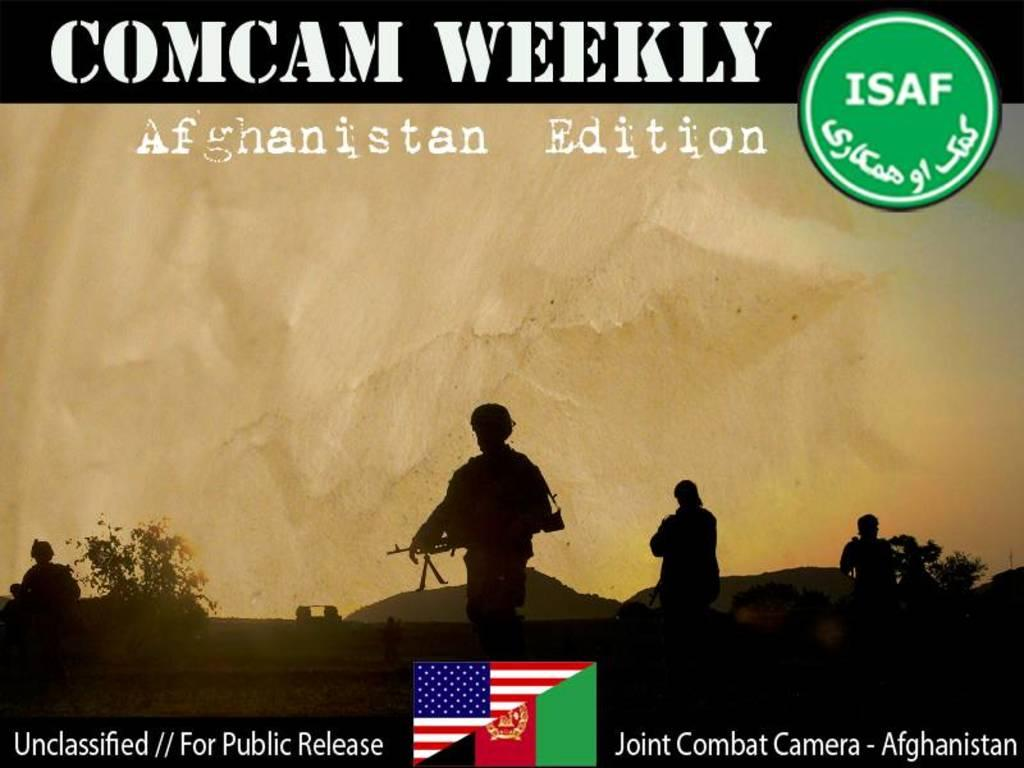<image>
Present a compact description of the photo's key features. Advertisement for a joint combat camera taking place in Afghanistan called Comcam Weekly. 